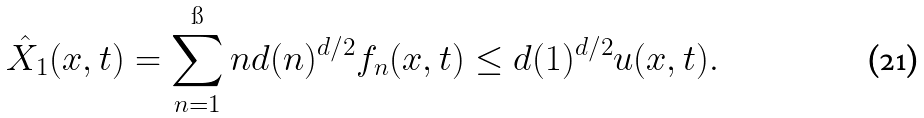Convert formula to latex. <formula><loc_0><loc_0><loc_500><loc_500>\hat { X } _ { 1 } ( x , t ) = \sum _ { n = 1 } ^ { \i } n d ( n ) ^ { d / 2 } f _ { n } ( x , t ) \leq d ( 1 ) ^ { d / 2 } u ( x , t ) .</formula> 